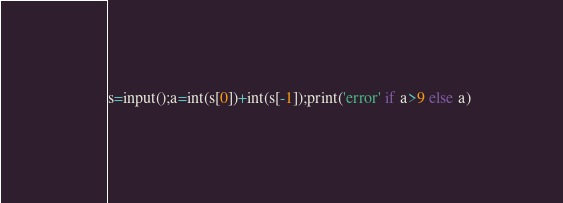Convert code to text. <code><loc_0><loc_0><loc_500><loc_500><_Python_>s=input();a=int(s[0])+int(s[-1]);print('error' if a>9 else a)</code> 